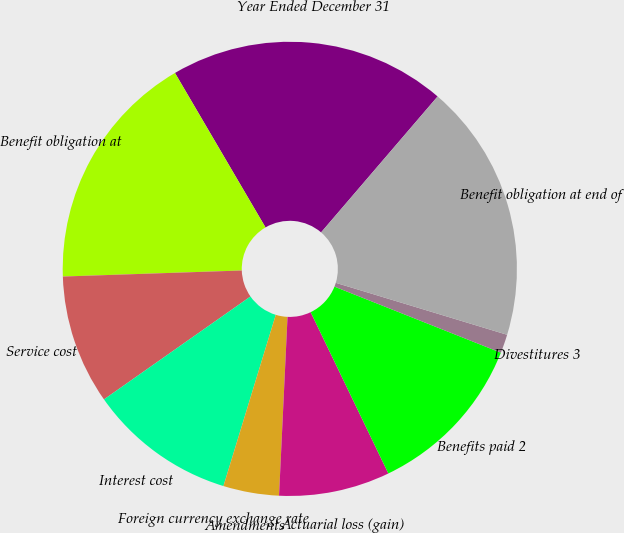Convert chart. <chart><loc_0><loc_0><loc_500><loc_500><pie_chart><fcel>Year Ended December 31<fcel>Benefit obligation at<fcel>Service cost<fcel>Interest cost<fcel>Foreign currency exchange rate<fcel>Amendments<fcel>Actuarial loss (gain)<fcel>Benefits paid 2<fcel>Divestitures 3<fcel>Benefit obligation at end of<nl><fcel>19.72%<fcel>17.1%<fcel>9.21%<fcel>10.53%<fcel>0.01%<fcel>3.96%<fcel>7.9%<fcel>11.84%<fcel>1.33%<fcel>18.41%<nl></chart> 